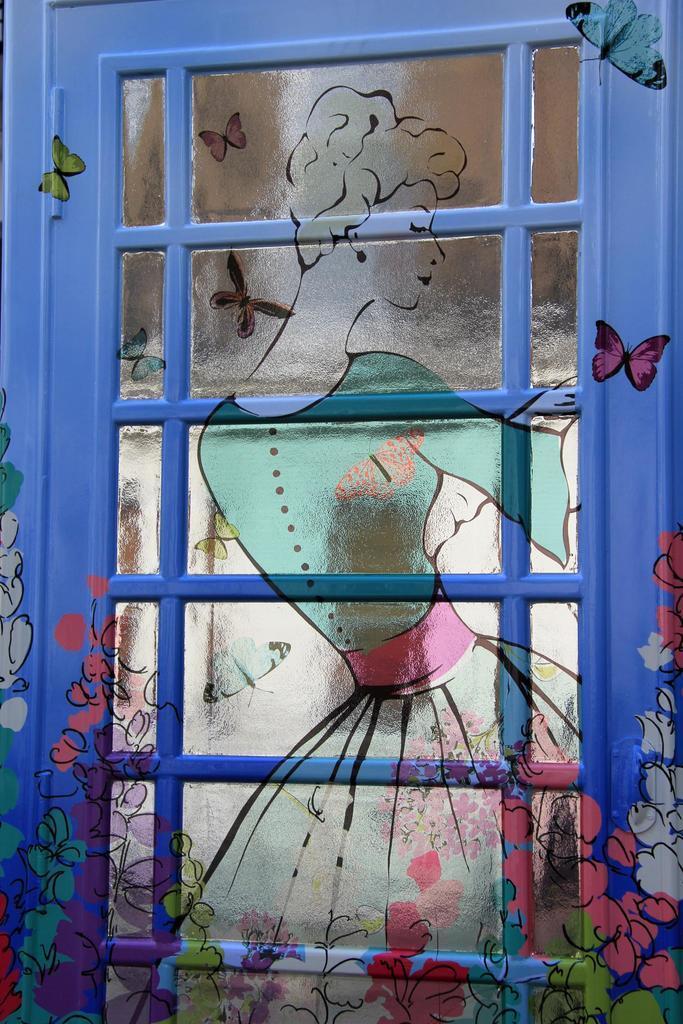Describe this image in one or two sentences. In the center of the image, we can see painting on the window. 